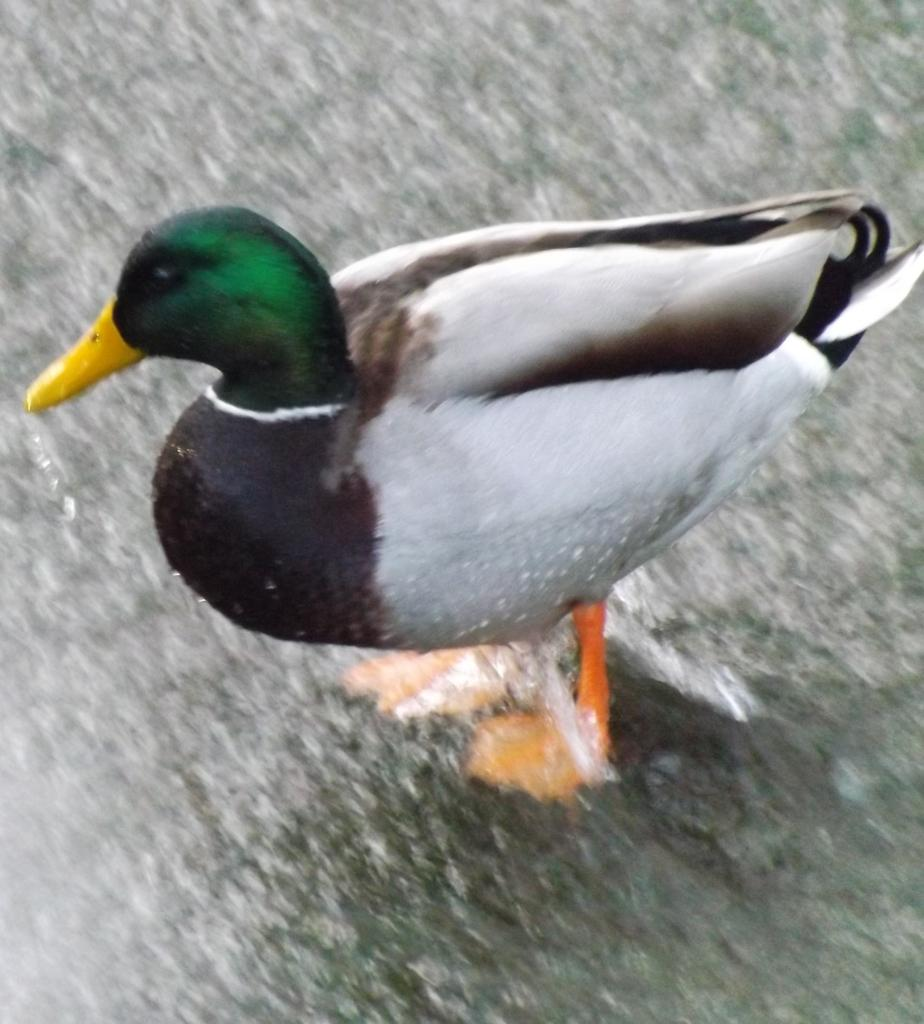What type of animal is in the image? There is a bird in the image. Where is the bird located? The bird is in the water. What colors can be seen on the bird? The bird has green, black, and white colors. What type of bean is floating next to the bird in the image? There is no bean present in the image; it only features a bird in the water. 